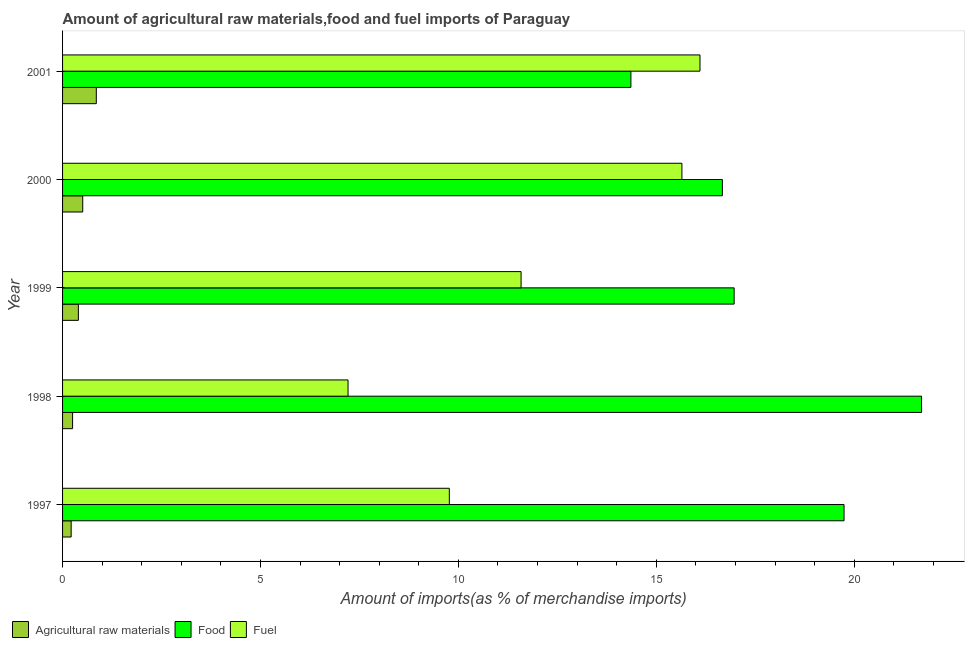How many different coloured bars are there?
Make the answer very short. 3. Are the number of bars on each tick of the Y-axis equal?
Provide a short and direct response. Yes. How many bars are there on the 5th tick from the bottom?
Your answer should be compact. 3. What is the label of the 1st group of bars from the top?
Keep it short and to the point. 2001. What is the percentage of raw materials imports in 1997?
Your answer should be compact. 0.22. Across all years, what is the maximum percentage of raw materials imports?
Your answer should be compact. 0.85. Across all years, what is the minimum percentage of food imports?
Keep it short and to the point. 14.36. What is the total percentage of food imports in the graph?
Offer a very short reply. 89.44. What is the difference between the percentage of fuel imports in 1997 and that in 1998?
Provide a short and direct response. 2.56. What is the difference between the percentage of food imports in 2001 and the percentage of raw materials imports in 2000?
Your response must be concise. 13.85. What is the average percentage of food imports per year?
Keep it short and to the point. 17.89. In the year 2001, what is the difference between the percentage of raw materials imports and percentage of fuel imports?
Provide a short and direct response. -15.25. In how many years, is the percentage of food imports greater than 16 %?
Ensure brevity in your answer.  4. What is the ratio of the percentage of food imports in 1997 to that in 1998?
Offer a very short reply. 0.91. Is the difference between the percentage of fuel imports in 1999 and 2001 greater than the difference between the percentage of food imports in 1999 and 2001?
Offer a terse response. No. What is the difference between the highest and the second highest percentage of fuel imports?
Keep it short and to the point. 0.46. What is the difference between the highest and the lowest percentage of fuel imports?
Provide a succinct answer. 8.89. What does the 3rd bar from the top in 1997 represents?
Provide a short and direct response. Agricultural raw materials. What does the 2nd bar from the bottom in 1999 represents?
Provide a succinct answer. Food. Is it the case that in every year, the sum of the percentage of raw materials imports and percentage of food imports is greater than the percentage of fuel imports?
Your response must be concise. No. How many bars are there?
Provide a succinct answer. 15. Are all the bars in the graph horizontal?
Provide a succinct answer. Yes. How many years are there in the graph?
Provide a succinct answer. 5. What is the difference between two consecutive major ticks on the X-axis?
Your answer should be very brief. 5. Does the graph contain any zero values?
Your answer should be compact. No. Does the graph contain grids?
Offer a very short reply. No. What is the title of the graph?
Provide a short and direct response. Amount of agricultural raw materials,food and fuel imports of Paraguay. Does "Social Protection" appear as one of the legend labels in the graph?
Offer a terse response. No. What is the label or title of the X-axis?
Your answer should be compact. Amount of imports(as % of merchandise imports). What is the label or title of the Y-axis?
Ensure brevity in your answer.  Year. What is the Amount of imports(as % of merchandise imports) of Agricultural raw materials in 1997?
Ensure brevity in your answer.  0.22. What is the Amount of imports(as % of merchandise imports) in Food in 1997?
Provide a short and direct response. 19.74. What is the Amount of imports(as % of merchandise imports) in Fuel in 1997?
Offer a very short reply. 9.77. What is the Amount of imports(as % of merchandise imports) of Agricultural raw materials in 1998?
Offer a very short reply. 0.25. What is the Amount of imports(as % of merchandise imports) in Food in 1998?
Your answer should be compact. 21.7. What is the Amount of imports(as % of merchandise imports) in Fuel in 1998?
Provide a succinct answer. 7.21. What is the Amount of imports(as % of merchandise imports) of Agricultural raw materials in 1999?
Your answer should be compact. 0.4. What is the Amount of imports(as % of merchandise imports) in Food in 1999?
Offer a terse response. 16.97. What is the Amount of imports(as % of merchandise imports) of Fuel in 1999?
Keep it short and to the point. 11.58. What is the Amount of imports(as % of merchandise imports) in Agricultural raw materials in 2000?
Your response must be concise. 0.51. What is the Amount of imports(as % of merchandise imports) of Food in 2000?
Provide a succinct answer. 16.67. What is the Amount of imports(as % of merchandise imports) of Fuel in 2000?
Your answer should be compact. 15.65. What is the Amount of imports(as % of merchandise imports) in Agricultural raw materials in 2001?
Provide a short and direct response. 0.85. What is the Amount of imports(as % of merchandise imports) of Food in 2001?
Your response must be concise. 14.36. What is the Amount of imports(as % of merchandise imports) of Fuel in 2001?
Your response must be concise. 16.1. Across all years, what is the maximum Amount of imports(as % of merchandise imports) in Agricultural raw materials?
Give a very brief answer. 0.85. Across all years, what is the maximum Amount of imports(as % of merchandise imports) of Food?
Your response must be concise. 21.7. Across all years, what is the maximum Amount of imports(as % of merchandise imports) of Fuel?
Offer a very short reply. 16.1. Across all years, what is the minimum Amount of imports(as % of merchandise imports) in Agricultural raw materials?
Your answer should be compact. 0.22. Across all years, what is the minimum Amount of imports(as % of merchandise imports) of Food?
Ensure brevity in your answer.  14.36. Across all years, what is the minimum Amount of imports(as % of merchandise imports) of Fuel?
Offer a terse response. 7.21. What is the total Amount of imports(as % of merchandise imports) of Agricultural raw materials in the graph?
Your response must be concise. 2.23. What is the total Amount of imports(as % of merchandise imports) of Food in the graph?
Provide a short and direct response. 89.44. What is the total Amount of imports(as % of merchandise imports) in Fuel in the graph?
Ensure brevity in your answer.  60.32. What is the difference between the Amount of imports(as % of merchandise imports) in Agricultural raw materials in 1997 and that in 1998?
Provide a succinct answer. -0.04. What is the difference between the Amount of imports(as % of merchandise imports) in Food in 1997 and that in 1998?
Your response must be concise. -1.96. What is the difference between the Amount of imports(as % of merchandise imports) in Fuel in 1997 and that in 1998?
Make the answer very short. 2.56. What is the difference between the Amount of imports(as % of merchandise imports) in Agricultural raw materials in 1997 and that in 1999?
Your response must be concise. -0.18. What is the difference between the Amount of imports(as % of merchandise imports) of Food in 1997 and that in 1999?
Your response must be concise. 2.78. What is the difference between the Amount of imports(as % of merchandise imports) in Fuel in 1997 and that in 1999?
Your answer should be very brief. -1.81. What is the difference between the Amount of imports(as % of merchandise imports) of Agricultural raw materials in 1997 and that in 2000?
Your answer should be very brief. -0.29. What is the difference between the Amount of imports(as % of merchandise imports) of Food in 1997 and that in 2000?
Offer a terse response. 3.07. What is the difference between the Amount of imports(as % of merchandise imports) in Fuel in 1997 and that in 2000?
Give a very brief answer. -5.88. What is the difference between the Amount of imports(as % of merchandise imports) of Agricultural raw materials in 1997 and that in 2001?
Keep it short and to the point. -0.64. What is the difference between the Amount of imports(as % of merchandise imports) of Food in 1997 and that in 2001?
Offer a terse response. 5.38. What is the difference between the Amount of imports(as % of merchandise imports) in Fuel in 1997 and that in 2001?
Ensure brevity in your answer.  -6.33. What is the difference between the Amount of imports(as % of merchandise imports) in Agricultural raw materials in 1998 and that in 1999?
Make the answer very short. -0.15. What is the difference between the Amount of imports(as % of merchandise imports) of Food in 1998 and that in 1999?
Your answer should be very brief. 4.73. What is the difference between the Amount of imports(as % of merchandise imports) of Fuel in 1998 and that in 1999?
Provide a succinct answer. -4.37. What is the difference between the Amount of imports(as % of merchandise imports) in Agricultural raw materials in 1998 and that in 2000?
Offer a terse response. -0.26. What is the difference between the Amount of imports(as % of merchandise imports) of Food in 1998 and that in 2000?
Your answer should be very brief. 5.03. What is the difference between the Amount of imports(as % of merchandise imports) in Fuel in 1998 and that in 2000?
Give a very brief answer. -8.43. What is the difference between the Amount of imports(as % of merchandise imports) of Agricultural raw materials in 1998 and that in 2001?
Provide a succinct answer. -0.6. What is the difference between the Amount of imports(as % of merchandise imports) in Food in 1998 and that in 2001?
Your answer should be very brief. 7.34. What is the difference between the Amount of imports(as % of merchandise imports) of Fuel in 1998 and that in 2001?
Keep it short and to the point. -8.89. What is the difference between the Amount of imports(as % of merchandise imports) in Agricultural raw materials in 1999 and that in 2000?
Provide a succinct answer. -0.11. What is the difference between the Amount of imports(as % of merchandise imports) in Food in 1999 and that in 2000?
Keep it short and to the point. 0.3. What is the difference between the Amount of imports(as % of merchandise imports) in Fuel in 1999 and that in 2000?
Keep it short and to the point. -4.06. What is the difference between the Amount of imports(as % of merchandise imports) of Agricultural raw materials in 1999 and that in 2001?
Provide a succinct answer. -0.45. What is the difference between the Amount of imports(as % of merchandise imports) in Food in 1999 and that in 2001?
Provide a succinct answer. 2.61. What is the difference between the Amount of imports(as % of merchandise imports) in Fuel in 1999 and that in 2001?
Your answer should be compact. -4.52. What is the difference between the Amount of imports(as % of merchandise imports) of Agricultural raw materials in 2000 and that in 2001?
Ensure brevity in your answer.  -0.34. What is the difference between the Amount of imports(as % of merchandise imports) in Food in 2000 and that in 2001?
Keep it short and to the point. 2.31. What is the difference between the Amount of imports(as % of merchandise imports) of Fuel in 2000 and that in 2001?
Make the answer very short. -0.46. What is the difference between the Amount of imports(as % of merchandise imports) in Agricultural raw materials in 1997 and the Amount of imports(as % of merchandise imports) in Food in 1998?
Your answer should be very brief. -21.48. What is the difference between the Amount of imports(as % of merchandise imports) in Agricultural raw materials in 1997 and the Amount of imports(as % of merchandise imports) in Fuel in 1998?
Provide a short and direct response. -7. What is the difference between the Amount of imports(as % of merchandise imports) in Food in 1997 and the Amount of imports(as % of merchandise imports) in Fuel in 1998?
Your response must be concise. 12.53. What is the difference between the Amount of imports(as % of merchandise imports) of Agricultural raw materials in 1997 and the Amount of imports(as % of merchandise imports) of Food in 1999?
Provide a succinct answer. -16.75. What is the difference between the Amount of imports(as % of merchandise imports) of Agricultural raw materials in 1997 and the Amount of imports(as % of merchandise imports) of Fuel in 1999?
Provide a succinct answer. -11.37. What is the difference between the Amount of imports(as % of merchandise imports) of Food in 1997 and the Amount of imports(as % of merchandise imports) of Fuel in 1999?
Your answer should be very brief. 8.16. What is the difference between the Amount of imports(as % of merchandise imports) in Agricultural raw materials in 1997 and the Amount of imports(as % of merchandise imports) in Food in 2000?
Keep it short and to the point. -16.45. What is the difference between the Amount of imports(as % of merchandise imports) of Agricultural raw materials in 1997 and the Amount of imports(as % of merchandise imports) of Fuel in 2000?
Your response must be concise. -15.43. What is the difference between the Amount of imports(as % of merchandise imports) of Food in 1997 and the Amount of imports(as % of merchandise imports) of Fuel in 2000?
Keep it short and to the point. 4.1. What is the difference between the Amount of imports(as % of merchandise imports) of Agricultural raw materials in 1997 and the Amount of imports(as % of merchandise imports) of Food in 2001?
Ensure brevity in your answer.  -14.14. What is the difference between the Amount of imports(as % of merchandise imports) in Agricultural raw materials in 1997 and the Amount of imports(as % of merchandise imports) in Fuel in 2001?
Make the answer very short. -15.89. What is the difference between the Amount of imports(as % of merchandise imports) of Food in 1997 and the Amount of imports(as % of merchandise imports) of Fuel in 2001?
Ensure brevity in your answer.  3.64. What is the difference between the Amount of imports(as % of merchandise imports) in Agricultural raw materials in 1998 and the Amount of imports(as % of merchandise imports) in Food in 1999?
Ensure brevity in your answer.  -16.71. What is the difference between the Amount of imports(as % of merchandise imports) in Agricultural raw materials in 1998 and the Amount of imports(as % of merchandise imports) in Fuel in 1999?
Offer a very short reply. -11.33. What is the difference between the Amount of imports(as % of merchandise imports) of Food in 1998 and the Amount of imports(as % of merchandise imports) of Fuel in 1999?
Provide a succinct answer. 10.12. What is the difference between the Amount of imports(as % of merchandise imports) of Agricultural raw materials in 1998 and the Amount of imports(as % of merchandise imports) of Food in 2000?
Offer a terse response. -16.42. What is the difference between the Amount of imports(as % of merchandise imports) in Agricultural raw materials in 1998 and the Amount of imports(as % of merchandise imports) in Fuel in 2000?
Keep it short and to the point. -15.39. What is the difference between the Amount of imports(as % of merchandise imports) of Food in 1998 and the Amount of imports(as % of merchandise imports) of Fuel in 2000?
Your answer should be compact. 6.05. What is the difference between the Amount of imports(as % of merchandise imports) in Agricultural raw materials in 1998 and the Amount of imports(as % of merchandise imports) in Food in 2001?
Your answer should be compact. -14.11. What is the difference between the Amount of imports(as % of merchandise imports) of Agricultural raw materials in 1998 and the Amount of imports(as % of merchandise imports) of Fuel in 2001?
Your response must be concise. -15.85. What is the difference between the Amount of imports(as % of merchandise imports) of Food in 1998 and the Amount of imports(as % of merchandise imports) of Fuel in 2001?
Your answer should be very brief. 5.6. What is the difference between the Amount of imports(as % of merchandise imports) in Agricultural raw materials in 1999 and the Amount of imports(as % of merchandise imports) in Food in 2000?
Keep it short and to the point. -16.27. What is the difference between the Amount of imports(as % of merchandise imports) of Agricultural raw materials in 1999 and the Amount of imports(as % of merchandise imports) of Fuel in 2000?
Offer a very short reply. -15.25. What is the difference between the Amount of imports(as % of merchandise imports) in Food in 1999 and the Amount of imports(as % of merchandise imports) in Fuel in 2000?
Keep it short and to the point. 1.32. What is the difference between the Amount of imports(as % of merchandise imports) in Agricultural raw materials in 1999 and the Amount of imports(as % of merchandise imports) in Food in 2001?
Keep it short and to the point. -13.96. What is the difference between the Amount of imports(as % of merchandise imports) in Agricultural raw materials in 1999 and the Amount of imports(as % of merchandise imports) in Fuel in 2001?
Ensure brevity in your answer.  -15.7. What is the difference between the Amount of imports(as % of merchandise imports) in Food in 1999 and the Amount of imports(as % of merchandise imports) in Fuel in 2001?
Give a very brief answer. 0.86. What is the difference between the Amount of imports(as % of merchandise imports) of Agricultural raw materials in 2000 and the Amount of imports(as % of merchandise imports) of Food in 2001?
Ensure brevity in your answer.  -13.85. What is the difference between the Amount of imports(as % of merchandise imports) of Agricultural raw materials in 2000 and the Amount of imports(as % of merchandise imports) of Fuel in 2001?
Offer a terse response. -15.59. What is the difference between the Amount of imports(as % of merchandise imports) in Food in 2000 and the Amount of imports(as % of merchandise imports) in Fuel in 2001?
Your answer should be compact. 0.57. What is the average Amount of imports(as % of merchandise imports) in Agricultural raw materials per year?
Give a very brief answer. 0.45. What is the average Amount of imports(as % of merchandise imports) in Food per year?
Your answer should be compact. 17.89. What is the average Amount of imports(as % of merchandise imports) in Fuel per year?
Ensure brevity in your answer.  12.06. In the year 1997, what is the difference between the Amount of imports(as % of merchandise imports) in Agricultural raw materials and Amount of imports(as % of merchandise imports) in Food?
Provide a succinct answer. -19.53. In the year 1997, what is the difference between the Amount of imports(as % of merchandise imports) of Agricultural raw materials and Amount of imports(as % of merchandise imports) of Fuel?
Your answer should be very brief. -9.55. In the year 1997, what is the difference between the Amount of imports(as % of merchandise imports) in Food and Amount of imports(as % of merchandise imports) in Fuel?
Offer a very short reply. 9.97. In the year 1998, what is the difference between the Amount of imports(as % of merchandise imports) of Agricultural raw materials and Amount of imports(as % of merchandise imports) of Food?
Make the answer very short. -21.45. In the year 1998, what is the difference between the Amount of imports(as % of merchandise imports) in Agricultural raw materials and Amount of imports(as % of merchandise imports) in Fuel?
Give a very brief answer. -6.96. In the year 1998, what is the difference between the Amount of imports(as % of merchandise imports) in Food and Amount of imports(as % of merchandise imports) in Fuel?
Your answer should be very brief. 14.49. In the year 1999, what is the difference between the Amount of imports(as % of merchandise imports) in Agricultural raw materials and Amount of imports(as % of merchandise imports) in Food?
Ensure brevity in your answer.  -16.57. In the year 1999, what is the difference between the Amount of imports(as % of merchandise imports) in Agricultural raw materials and Amount of imports(as % of merchandise imports) in Fuel?
Your answer should be very brief. -11.18. In the year 1999, what is the difference between the Amount of imports(as % of merchandise imports) of Food and Amount of imports(as % of merchandise imports) of Fuel?
Your answer should be very brief. 5.38. In the year 2000, what is the difference between the Amount of imports(as % of merchandise imports) of Agricultural raw materials and Amount of imports(as % of merchandise imports) of Food?
Your response must be concise. -16.16. In the year 2000, what is the difference between the Amount of imports(as % of merchandise imports) in Agricultural raw materials and Amount of imports(as % of merchandise imports) in Fuel?
Your response must be concise. -15.14. In the year 2000, what is the difference between the Amount of imports(as % of merchandise imports) in Food and Amount of imports(as % of merchandise imports) in Fuel?
Provide a short and direct response. 1.02. In the year 2001, what is the difference between the Amount of imports(as % of merchandise imports) of Agricultural raw materials and Amount of imports(as % of merchandise imports) of Food?
Keep it short and to the point. -13.51. In the year 2001, what is the difference between the Amount of imports(as % of merchandise imports) of Agricultural raw materials and Amount of imports(as % of merchandise imports) of Fuel?
Your answer should be very brief. -15.25. In the year 2001, what is the difference between the Amount of imports(as % of merchandise imports) of Food and Amount of imports(as % of merchandise imports) of Fuel?
Make the answer very short. -1.75. What is the ratio of the Amount of imports(as % of merchandise imports) of Agricultural raw materials in 1997 to that in 1998?
Offer a terse response. 0.86. What is the ratio of the Amount of imports(as % of merchandise imports) in Food in 1997 to that in 1998?
Give a very brief answer. 0.91. What is the ratio of the Amount of imports(as % of merchandise imports) in Fuel in 1997 to that in 1998?
Give a very brief answer. 1.35. What is the ratio of the Amount of imports(as % of merchandise imports) in Agricultural raw materials in 1997 to that in 1999?
Provide a short and direct response. 0.54. What is the ratio of the Amount of imports(as % of merchandise imports) in Food in 1997 to that in 1999?
Provide a succinct answer. 1.16. What is the ratio of the Amount of imports(as % of merchandise imports) in Fuel in 1997 to that in 1999?
Your response must be concise. 0.84. What is the ratio of the Amount of imports(as % of merchandise imports) in Agricultural raw materials in 1997 to that in 2000?
Ensure brevity in your answer.  0.43. What is the ratio of the Amount of imports(as % of merchandise imports) of Food in 1997 to that in 2000?
Offer a terse response. 1.18. What is the ratio of the Amount of imports(as % of merchandise imports) in Fuel in 1997 to that in 2000?
Provide a succinct answer. 0.62. What is the ratio of the Amount of imports(as % of merchandise imports) of Agricultural raw materials in 1997 to that in 2001?
Offer a terse response. 0.25. What is the ratio of the Amount of imports(as % of merchandise imports) in Food in 1997 to that in 2001?
Keep it short and to the point. 1.38. What is the ratio of the Amount of imports(as % of merchandise imports) of Fuel in 1997 to that in 2001?
Your answer should be very brief. 0.61. What is the ratio of the Amount of imports(as % of merchandise imports) in Agricultural raw materials in 1998 to that in 1999?
Ensure brevity in your answer.  0.63. What is the ratio of the Amount of imports(as % of merchandise imports) of Food in 1998 to that in 1999?
Your answer should be compact. 1.28. What is the ratio of the Amount of imports(as % of merchandise imports) in Fuel in 1998 to that in 1999?
Your answer should be very brief. 0.62. What is the ratio of the Amount of imports(as % of merchandise imports) of Agricultural raw materials in 1998 to that in 2000?
Your answer should be very brief. 0.5. What is the ratio of the Amount of imports(as % of merchandise imports) in Food in 1998 to that in 2000?
Your response must be concise. 1.3. What is the ratio of the Amount of imports(as % of merchandise imports) of Fuel in 1998 to that in 2000?
Offer a very short reply. 0.46. What is the ratio of the Amount of imports(as % of merchandise imports) in Agricultural raw materials in 1998 to that in 2001?
Provide a succinct answer. 0.3. What is the ratio of the Amount of imports(as % of merchandise imports) of Food in 1998 to that in 2001?
Offer a terse response. 1.51. What is the ratio of the Amount of imports(as % of merchandise imports) of Fuel in 1998 to that in 2001?
Your response must be concise. 0.45. What is the ratio of the Amount of imports(as % of merchandise imports) of Agricultural raw materials in 1999 to that in 2000?
Make the answer very short. 0.78. What is the ratio of the Amount of imports(as % of merchandise imports) in Food in 1999 to that in 2000?
Make the answer very short. 1.02. What is the ratio of the Amount of imports(as % of merchandise imports) of Fuel in 1999 to that in 2000?
Offer a very short reply. 0.74. What is the ratio of the Amount of imports(as % of merchandise imports) in Agricultural raw materials in 1999 to that in 2001?
Give a very brief answer. 0.47. What is the ratio of the Amount of imports(as % of merchandise imports) in Food in 1999 to that in 2001?
Provide a short and direct response. 1.18. What is the ratio of the Amount of imports(as % of merchandise imports) of Fuel in 1999 to that in 2001?
Offer a terse response. 0.72. What is the ratio of the Amount of imports(as % of merchandise imports) of Agricultural raw materials in 2000 to that in 2001?
Your response must be concise. 0.6. What is the ratio of the Amount of imports(as % of merchandise imports) of Food in 2000 to that in 2001?
Provide a short and direct response. 1.16. What is the ratio of the Amount of imports(as % of merchandise imports) of Fuel in 2000 to that in 2001?
Your response must be concise. 0.97. What is the difference between the highest and the second highest Amount of imports(as % of merchandise imports) in Agricultural raw materials?
Provide a succinct answer. 0.34. What is the difference between the highest and the second highest Amount of imports(as % of merchandise imports) in Food?
Your answer should be very brief. 1.96. What is the difference between the highest and the second highest Amount of imports(as % of merchandise imports) in Fuel?
Keep it short and to the point. 0.46. What is the difference between the highest and the lowest Amount of imports(as % of merchandise imports) in Agricultural raw materials?
Your answer should be very brief. 0.64. What is the difference between the highest and the lowest Amount of imports(as % of merchandise imports) of Food?
Your answer should be very brief. 7.34. What is the difference between the highest and the lowest Amount of imports(as % of merchandise imports) in Fuel?
Ensure brevity in your answer.  8.89. 